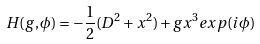Convert formula to latex. <formula><loc_0><loc_0><loc_500><loc_500>H ( g , \phi ) = - \frac { 1 } { 2 } ( D ^ { 2 } + x ^ { 2 } ) + g x ^ { 3 } e x p ( i \phi )</formula> 